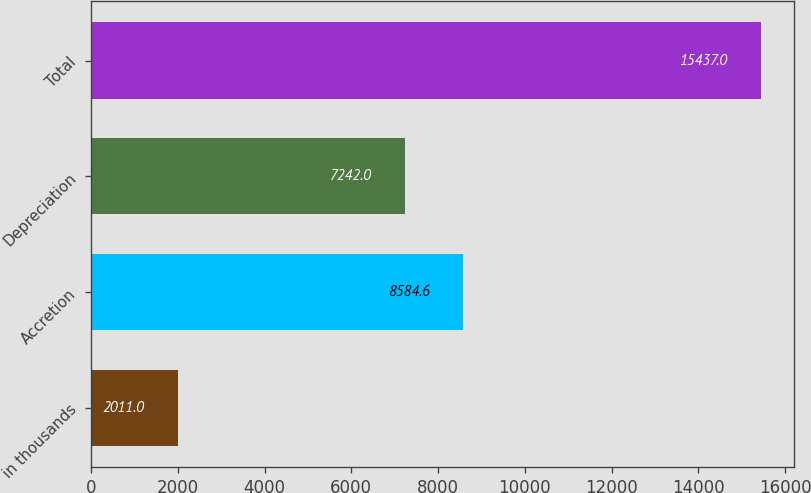Convert chart to OTSL. <chart><loc_0><loc_0><loc_500><loc_500><bar_chart><fcel>in thousands<fcel>Accretion<fcel>Depreciation<fcel>Total<nl><fcel>2011<fcel>8584.6<fcel>7242<fcel>15437<nl></chart> 